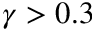<formula> <loc_0><loc_0><loc_500><loc_500>\gamma > 0 . 3</formula> 